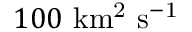<formula> <loc_0><loc_0><loc_500><loc_500>1 0 0 \ k m ^ { 2 } \ s ^ { - 1 }</formula> 